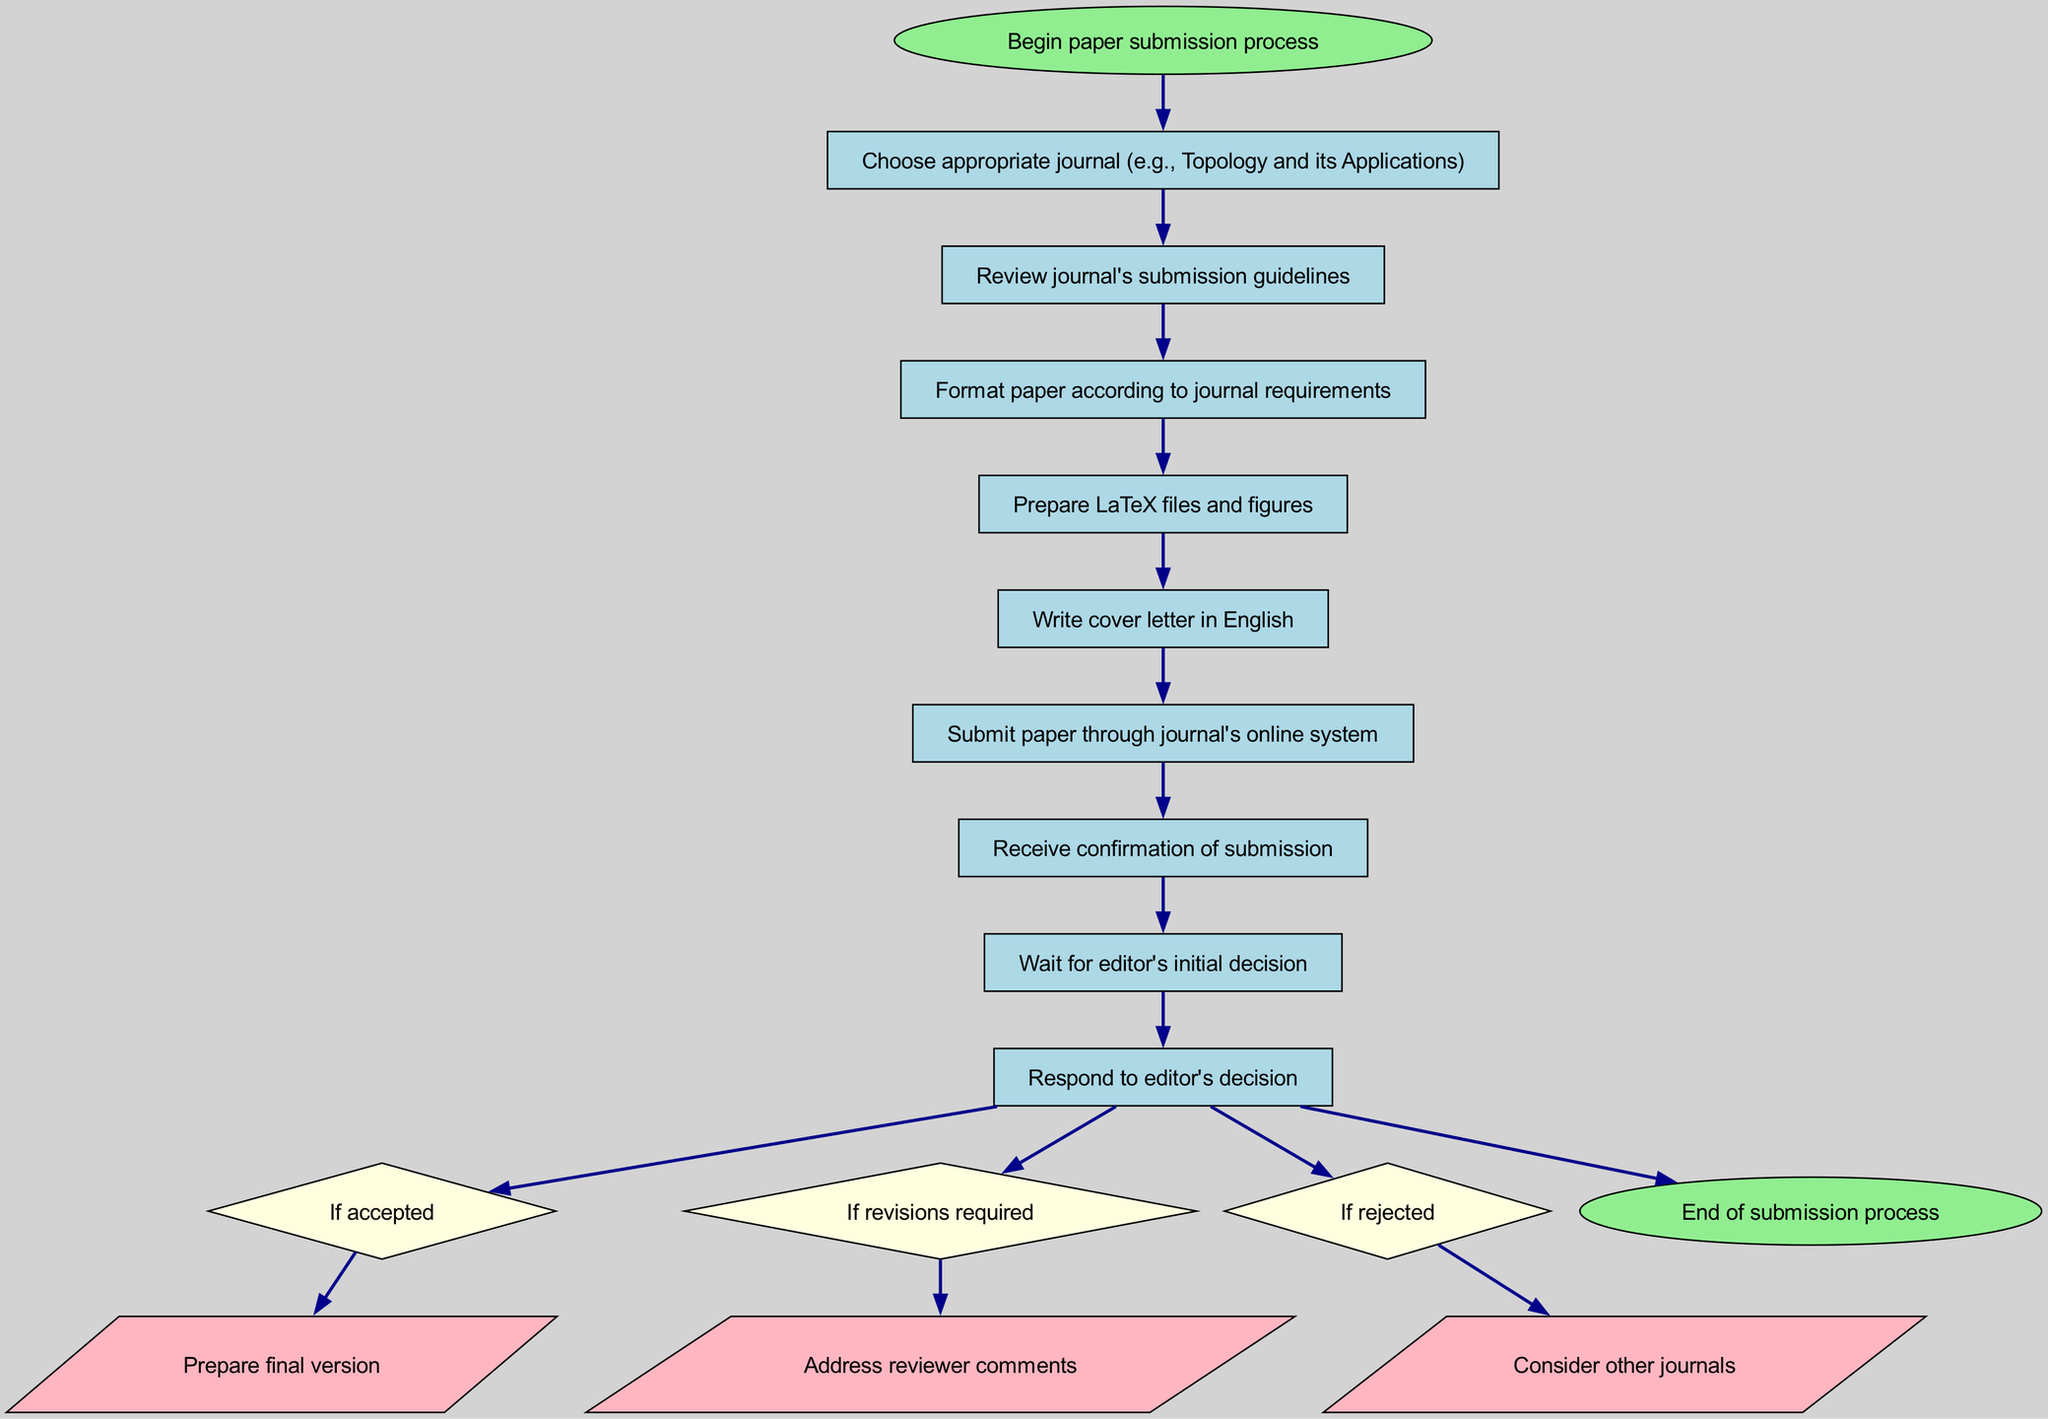What is the first step in the submission process? The first step listed in the diagram is "Choose appropriate journal (e.g., Topology and its Applications)". This step is directly connected to the start node, indicating it is the initial action to take.
Answer: Choose appropriate journal (e.g., Topology and its Applications) How many steps are there in the submission process? By counting the steps outlined in the diagram, I see there are a total of 8 numbered steps listed before the end node.
Answer: 8 What action follows if the paper is accepted? In the diagram, if the editor's decision is "If accepted", the next action to take is "Prepare final version." This is shown as a specific option from the decision node.
Answer: Prepare final version What do you do after receiving confirmation of submission? After the confirmation of submission, the diagram indicates to "Wait for editor's initial decision" as the next step in the process. This action is sequentially linked to the previous one.
Answer: Wait for editor's initial decision What is the last node in the flowchart? The last node in the flowchart is "End of submission process", which indicates the conclusion of the entire submission process. This node follows all steps and decisions made.
Answer: End of submission process What should you do if the editor requires revisions? According to the diagram, if revisions are required by the editor, the action specified is "Address reviewer comments". This response is presented as one of the options stemming from the editor's decision node.
Answer: Address reviewer comments How does one submit the paper? The submission of the paper is done "through journal's online system", as indicated in step 6 of the diagram. This is a clear instruction for the submission action.
Answer: Through journal's online system What is indicated in step 4? Step 4 of the diagram instructs to "Prepare LaTeX files and figures". This gives specific content preparation tasks necessary for submission.
Answer: Prepare LaTeX files and figures 